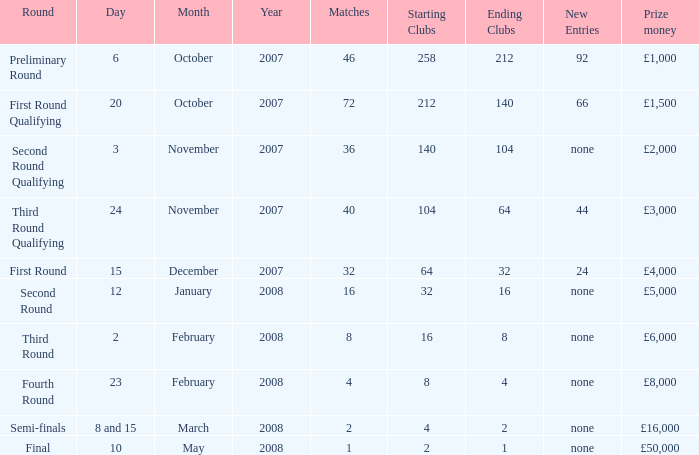How many new entries this round have clubs 2 → 1? None. 